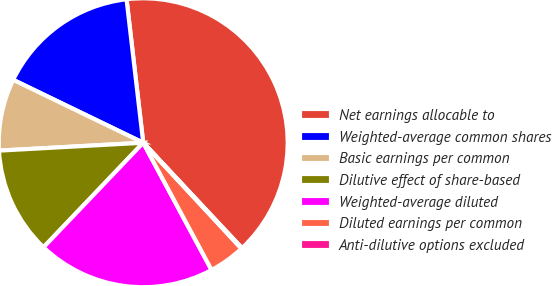Convert chart. <chart><loc_0><loc_0><loc_500><loc_500><pie_chart><fcel>Net earnings allocable to<fcel>Weighted-average common shares<fcel>Basic earnings per common<fcel>Dilutive effect of share-based<fcel>Weighted-average diluted<fcel>Diluted earnings per common<fcel>Anti-dilutive options excluded<nl><fcel>39.86%<fcel>15.99%<fcel>8.04%<fcel>12.01%<fcel>19.97%<fcel>4.06%<fcel>0.08%<nl></chart> 